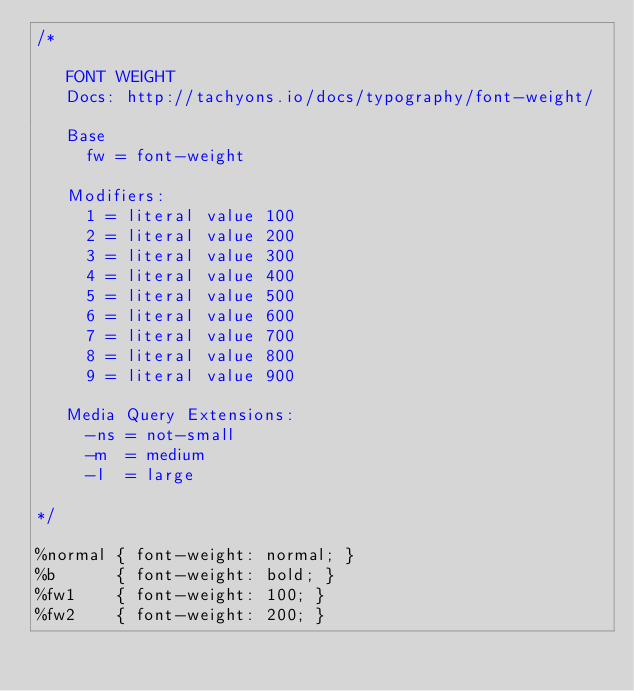<code> <loc_0><loc_0><loc_500><loc_500><_CSS_>/*

   FONT WEIGHT
   Docs: http://tachyons.io/docs/typography/font-weight/

   Base
     fw = font-weight

   Modifiers:
     1 = literal value 100
     2 = literal value 200
     3 = literal value 300
     4 = literal value 400
     5 = literal value 500
     6 = literal value 600
     7 = literal value 700
     8 = literal value 800
     9 = literal value 900

   Media Query Extensions:
     -ns = not-small
     -m  = medium
     -l  = large

*/

%normal { font-weight: normal; }
%b      { font-weight: bold; }
%fw1    { font-weight: 100; }
%fw2    { font-weight: 200; }</code> 